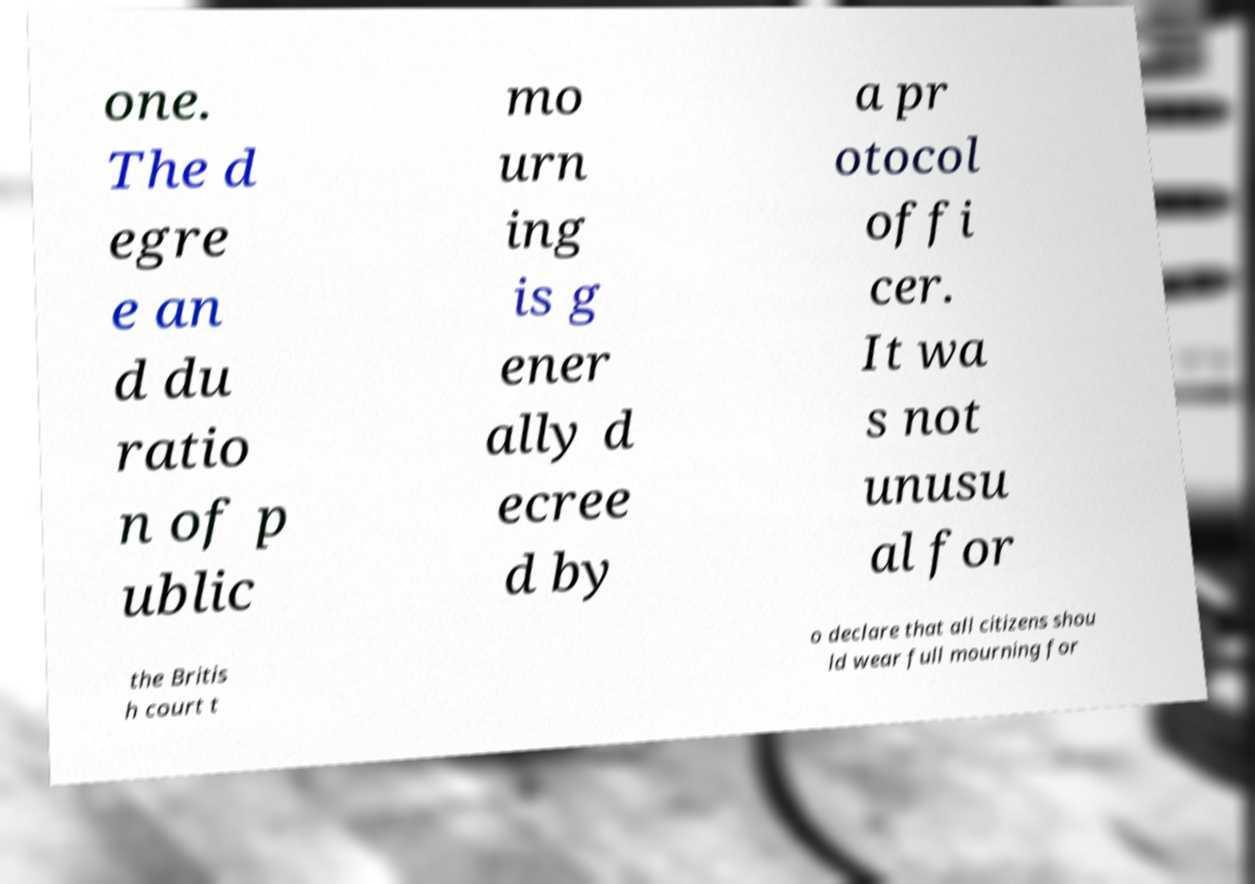What messages or text are displayed in this image? I need them in a readable, typed format. one. The d egre e an d du ratio n of p ublic mo urn ing is g ener ally d ecree d by a pr otocol offi cer. It wa s not unusu al for the Britis h court t o declare that all citizens shou ld wear full mourning for 